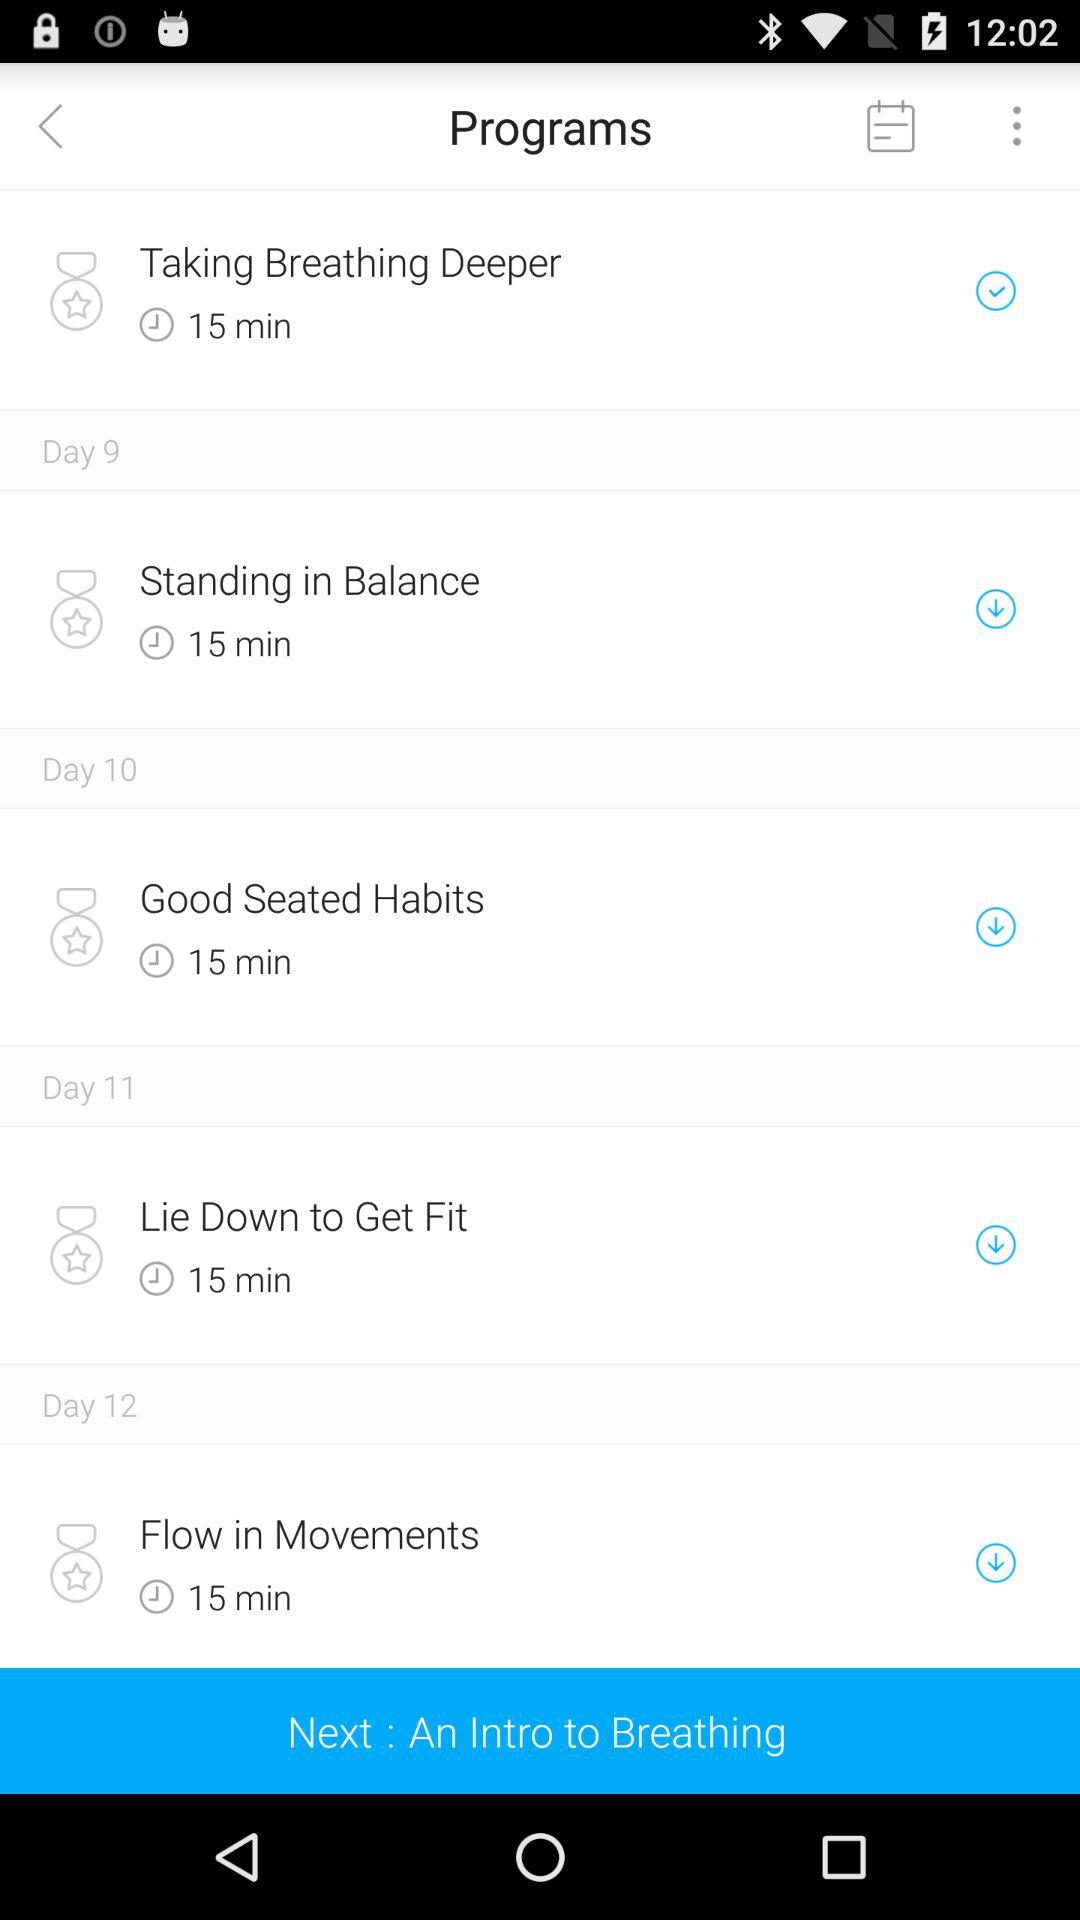How long is the program "Standing in Balance"? The program "Standing in Balance" is 15 minutes long. 